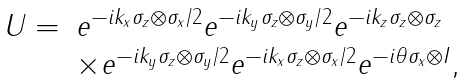Convert formula to latex. <formula><loc_0><loc_0><loc_500><loc_500>\begin{array} { l l } U = & e ^ { - i k _ { x } \sigma _ { z } \otimes \sigma _ { x } / 2 } e ^ { - i k _ { y } \sigma _ { z } \otimes \sigma _ { y } / 2 } e ^ { - i k _ { z } \sigma _ { z } \otimes \sigma _ { z } } \\ & \times e ^ { - i k _ { y } \sigma _ { z } \otimes \sigma _ { y } / 2 } e ^ { - i k _ { x } \sigma _ { z } \otimes \sigma _ { x } / 2 } e ^ { - i \theta \sigma _ { x } \otimes I } , \end{array}</formula> 